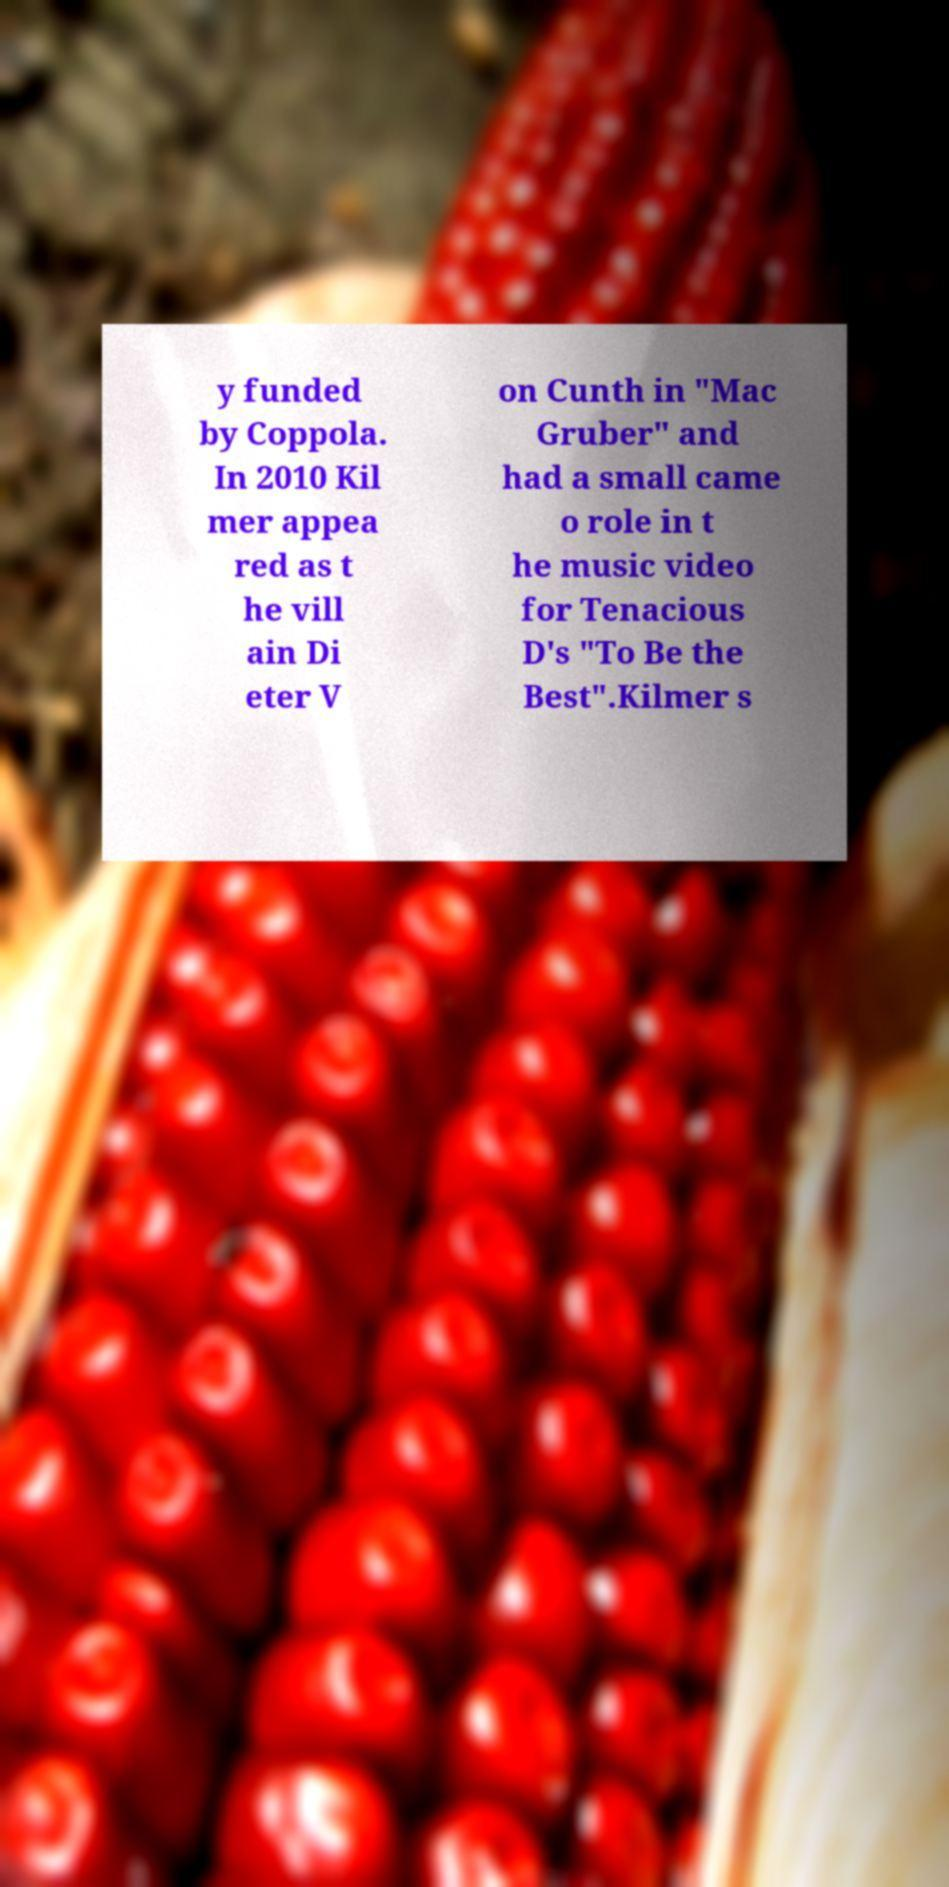Could you assist in decoding the text presented in this image and type it out clearly? y funded by Coppola. In 2010 Kil mer appea red as t he vill ain Di eter V on Cunth in "Mac Gruber" and had a small came o role in t he music video for Tenacious D's "To Be the Best".Kilmer s 